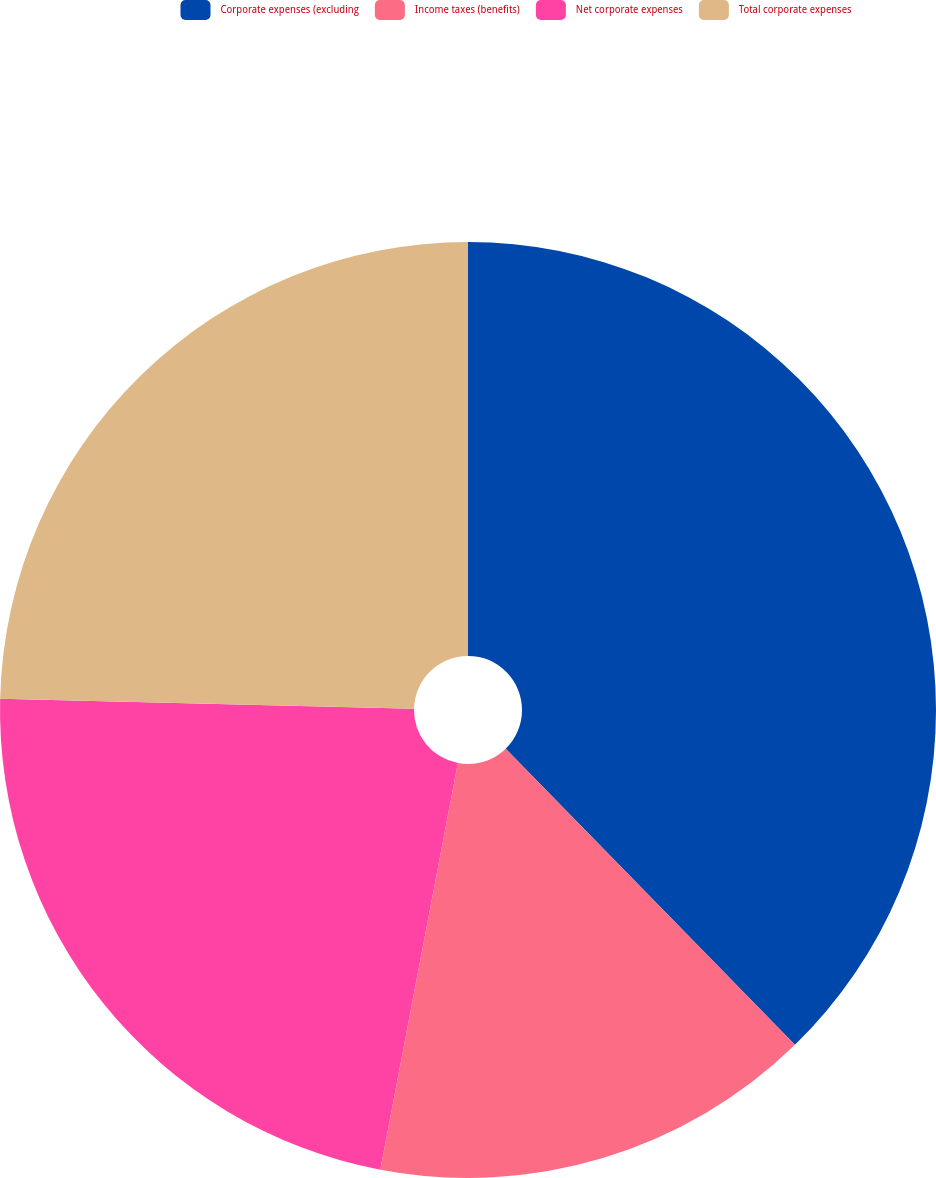Convert chart. <chart><loc_0><loc_0><loc_500><loc_500><pie_chart><fcel>Corporate expenses (excluding<fcel>Income taxes (benefits)<fcel>Net corporate expenses<fcel>Total corporate expenses<nl><fcel>37.69%<fcel>15.31%<fcel>22.38%<fcel>24.62%<nl></chart> 